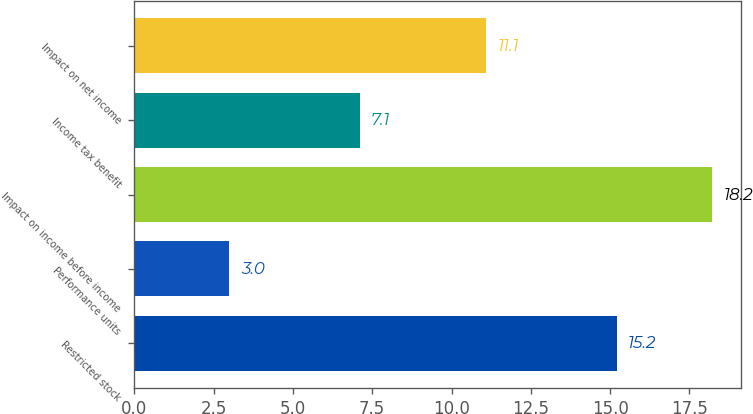<chart> <loc_0><loc_0><loc_500><loc_500><bar_chart><fcel>Restricted stock<fcel>Performance units<fcel>Impact on income before income<fcel>Income tax benefit<fcel>Impact on net income<nl><fcel>15.2<fcel>3<fcel>18.2<fcel>7.1<fcel>11.1<nl></chart> 